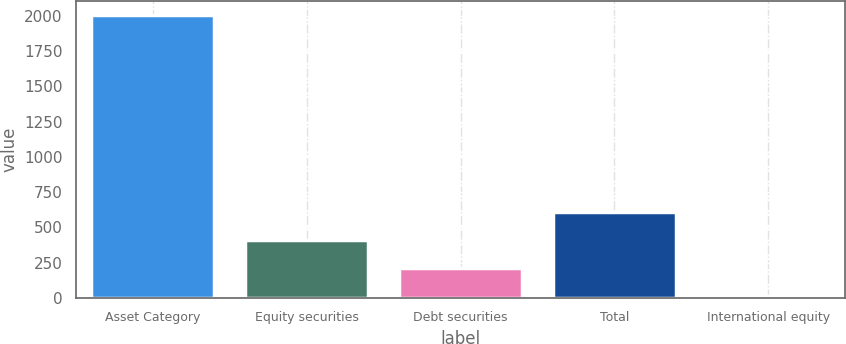Convert chart. <chart><loc_0><loc_0><loc_500><loc_500><bar_chart><fcel>Asset Category<fcel>Equity securities<fcel>Debt securities<fcel>Total<fcel>International equity<nl><fcel>2005<fcel>409.8<fcel>210.4<fcel>609.2<fcel>11<nl></chart> 